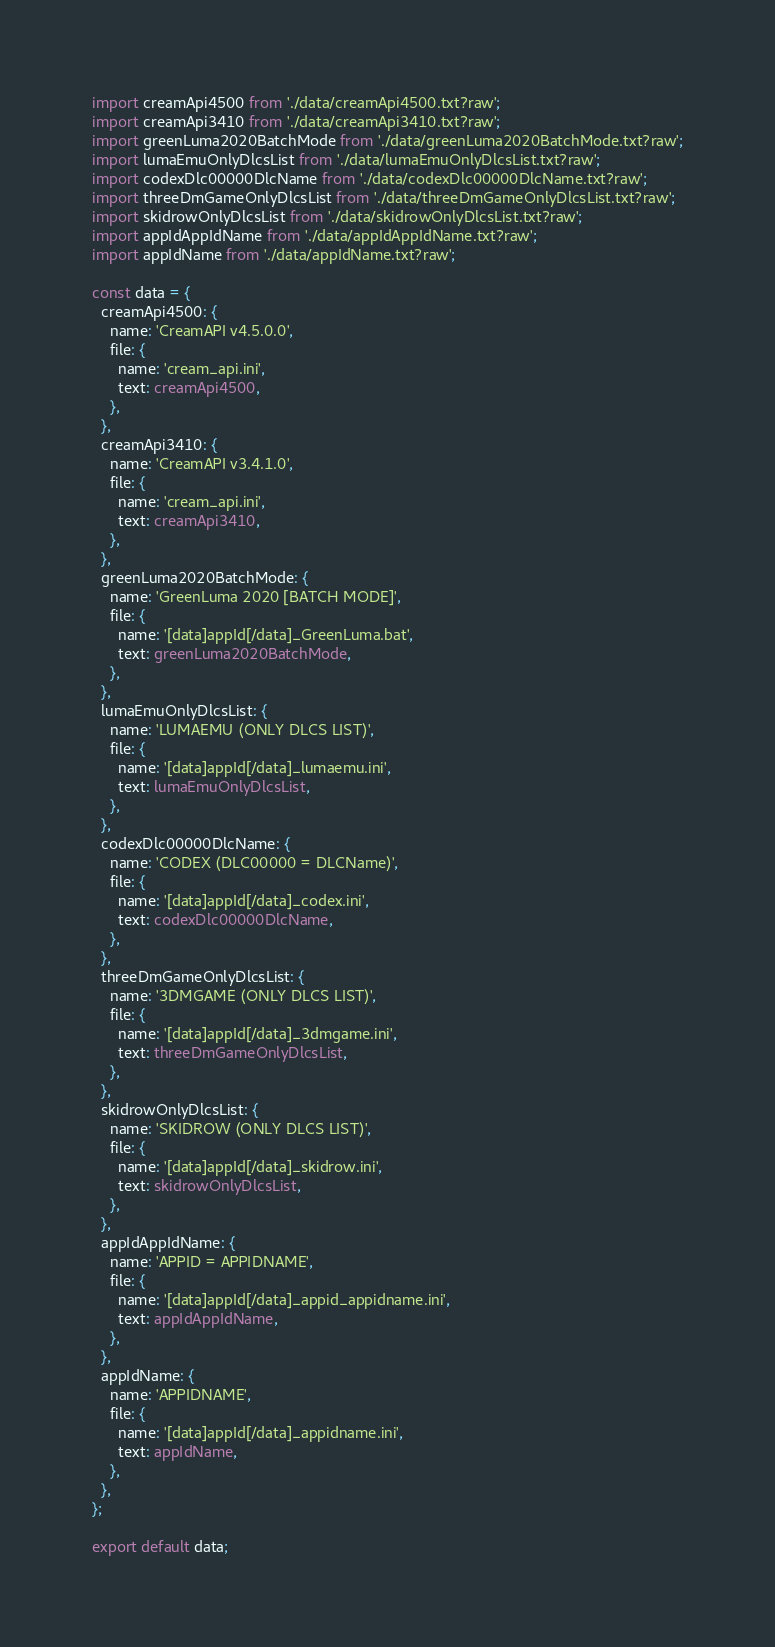<code> <loc_0><loc_0><loc_500><loc_500><_TypeScript_>import creamApi4500 from './data/creamApi4500.txt?raw';
import creamApi3410 from './data/creamApi3410.txt?raw';
import greenLuma2020BatchMode from './data/greenLuma2020BatchMode.txt?raw';
import lumaEmuOnlyDlcsList from './data/lumaEmuOnlyDlcsList.txt?raw';
import codexDlc00000DlcName from './data/codexDlc00000DlcName.txt?raw';
import threeDmGameOnlyDlcsList from './data/threeDmGameOnlyDlcsList.txt?raw';
import skidrowOnlyDlcsList from './data/skidrowOnlyDlcsList.txt?raw';
import appIdAppIdName from './data/appIdAppIdName.txt?raw';
import appIdName from './data/appIdName.txt?raw';

const data = {
  creamApi4500: {
    name: 'CreamAPI v4.5.0.0',
    file: {
      name: 'cream_api.ini',
      text: creamApi4500,
    },
  },
  creamApi3410: {
    name: 'CreamAPI v3.4.1.0',
    file: {
      name: 'cream_api.ini',
      text: creamApi3410,
    },
  },
  greenLuma2020BatchMode: {
    name: 'GreenLuma 2020 [BATCH MODE]',
    file: {
      name: '[data]appId[/data]_GreenLuma.bat',
      text: greenLuma2020BatchMode,
    },
  },
  lumaEmuOnlyDlcsList: {
    name: 'LUMAEMU (ONLY DLCS LIST)',
    file: {
      name: '[data]appId[/data]_lumaemu.ini',
      text: lumaEmuOnlyDlcsList,
    },
  },
  codexDlc00000DlcName: {
    name: 'CODEX (DLC00000 = DLCName)',
    file: {
      name: '[data]appId[/data]_codex.ini',
      text: codexDlc00000DlcName,
    },
  },
  threeDmGameOnlyDlcsList: {
    name: '3DMGAME (ONLY DLCS LIST)',
    file: {
      name: '[data]appId[/data]_3dmgame.ini',
      text: threeDmGameOnlyDlcsList,
    },
  },
  skidrowOnlyDlcsList: {
    name: 'SKIDROW (ONLY DLCS LIST)',
    file: {
      name: '[data]appId[/data]_skidrow.ini',
      text: skidrowOnlyDlcsList,
    },
  },
  appIdAppIdName: {
    name: 'APPID = APPIDNAME',
    file: {
      name: '[data]appId[/data]_appid_appidname.ini',
      text: appIdAppIdName,
    },
  },
  appIdName: {
    name: 'APPIDNAME',
    file: {
      name: '[data]appId[/data]_appidname.ini',
      text: appIdName,
    },
  },
};

export default data;
</code> 